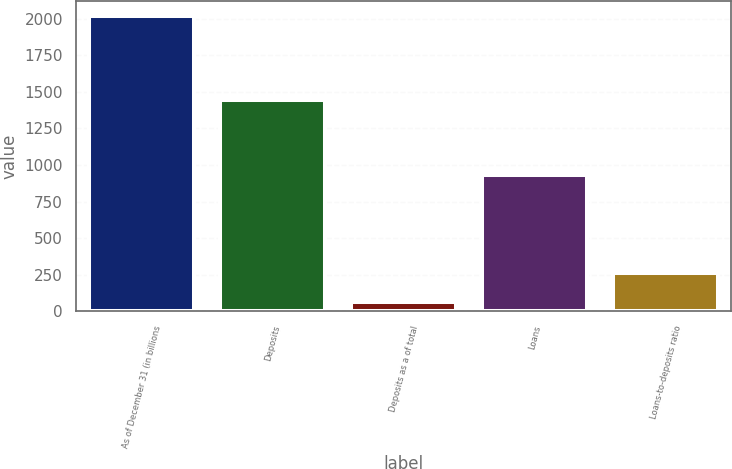Convert chart to OTSL. <chart><loc_0><loc_0><loc_500><loc_500><bar_chart><fcel>As of December 31 (in billions<fcel>Deposits<fcel>Deposits as a of total<fcel>Loans<fcel>Loans-to-deposits ratio<nl><fcel>2017<fcel>1444<fcel>63<fcel>930.7<fcel>258.4<nl></chart> 